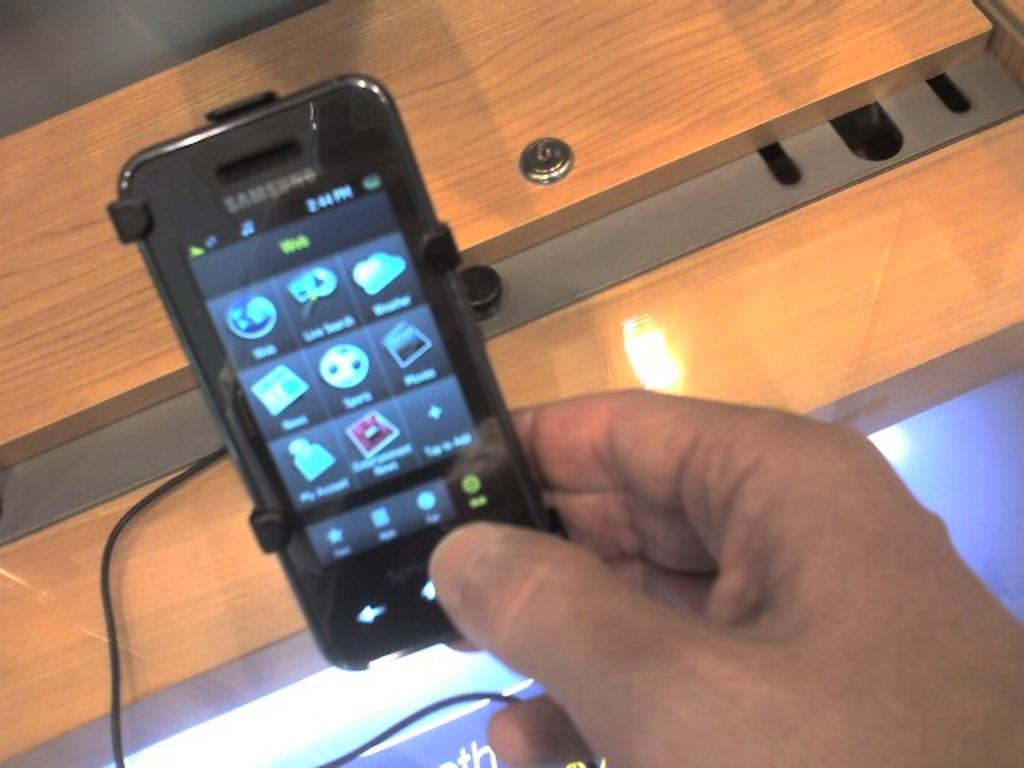<image>
Describe the image concisely. the word web is in green on a phone 